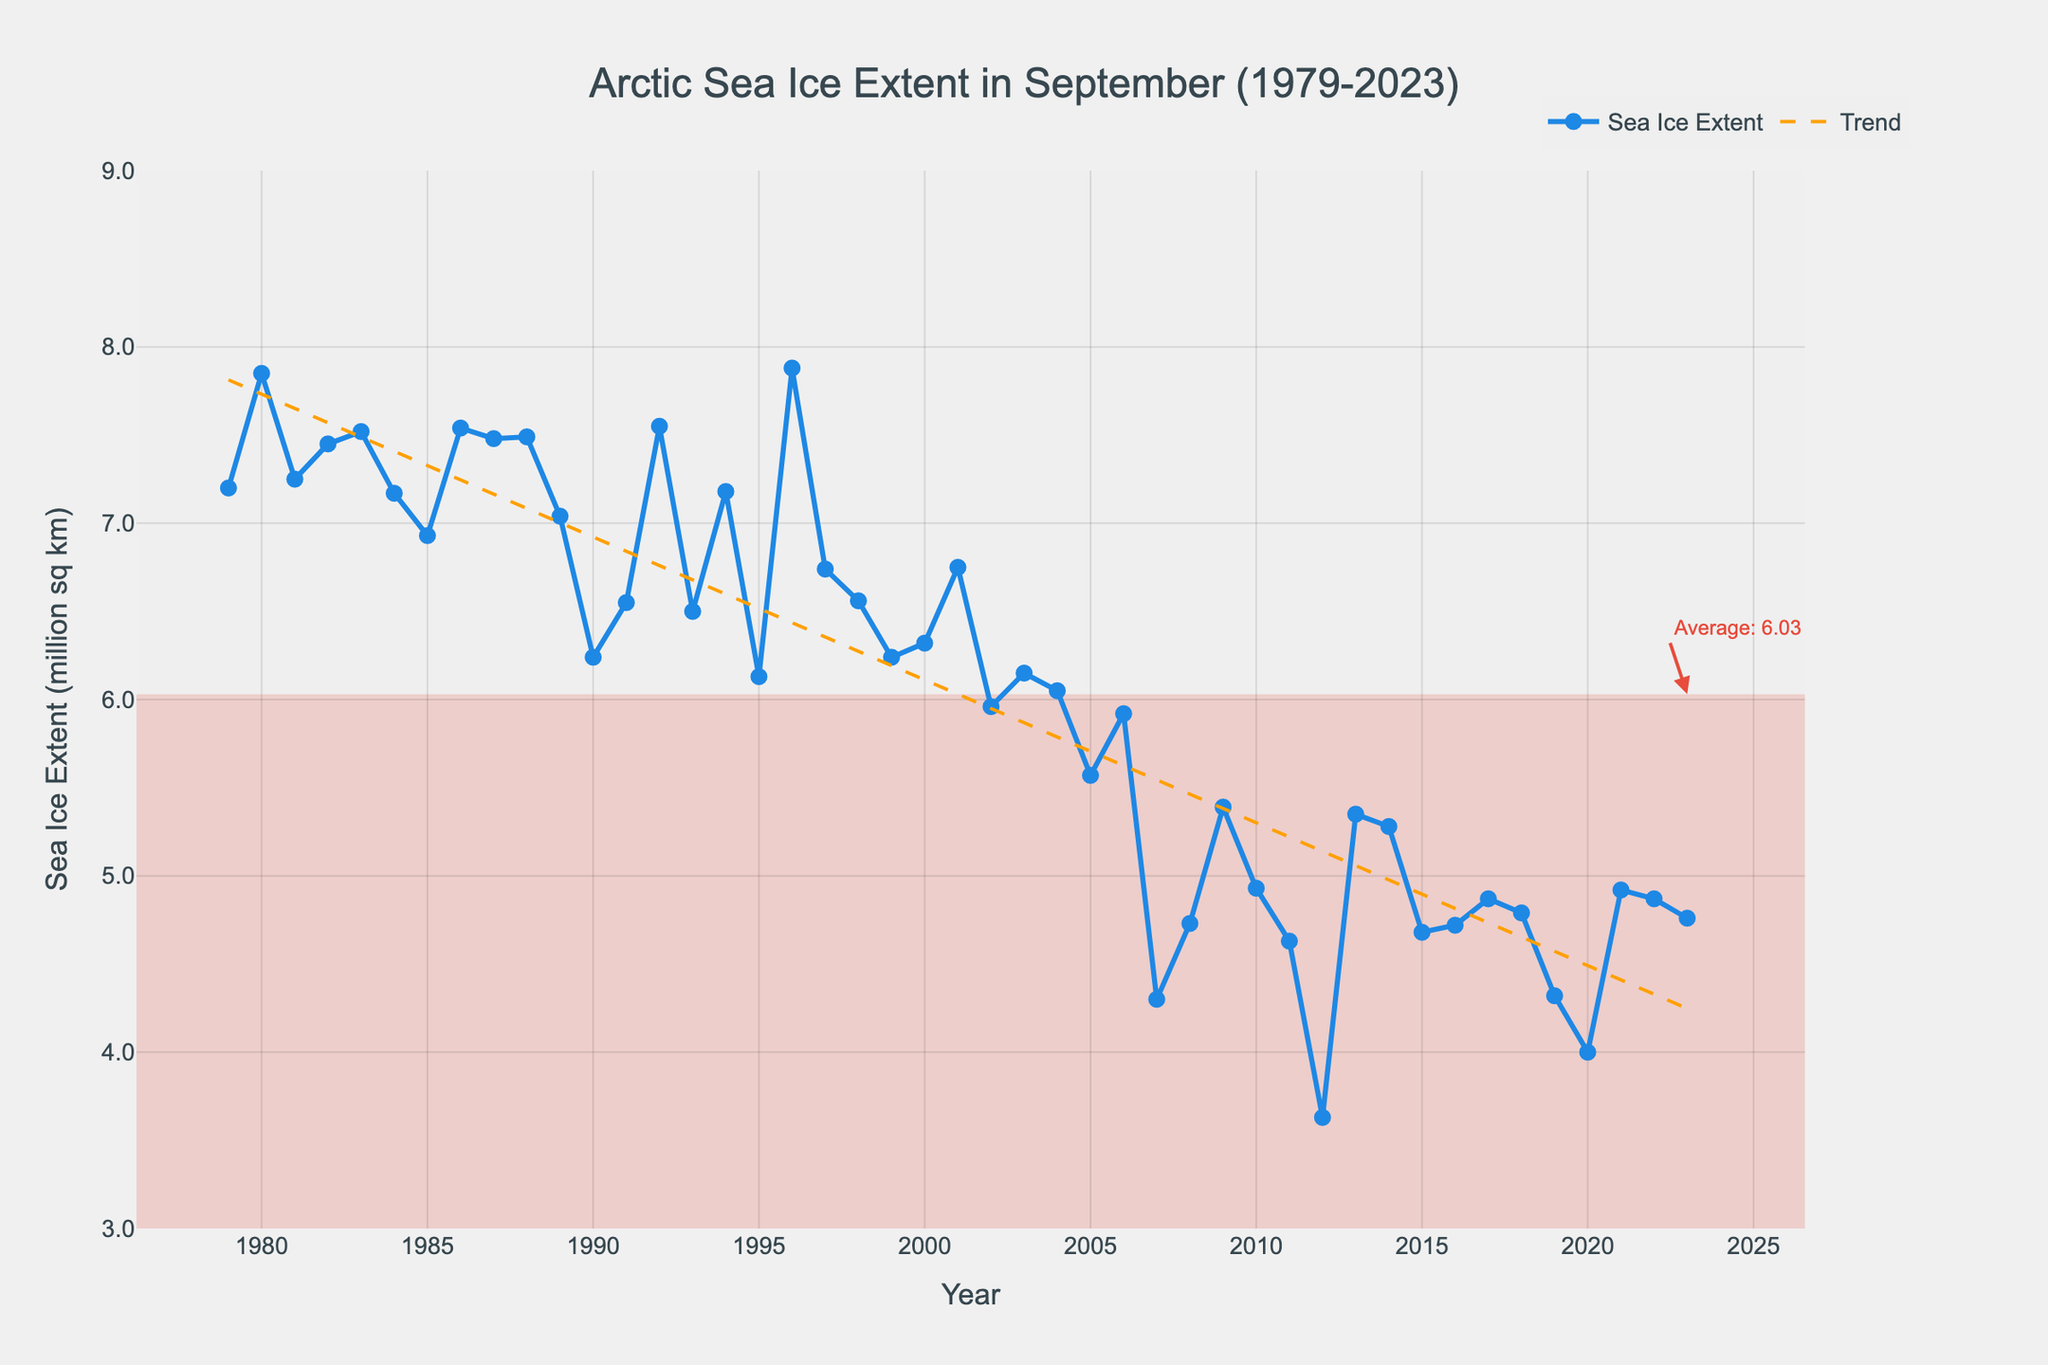what trend can be observed in the Arctic sea ice extent from 1979 to 2023? The trend line shows a decline in the sea ice extent from 1979 to 2023. This is depicted by the negative slope of the trend line, indicating that the extent of the sea ice in September has been decreasing steadily over the years.
Answer: Decreasing When was the lowest sea ice extent recorded, and what was its value? The lowest sea ice extent was recorded in the year 2012, as seen by the lowest point on the line chart, and its value was around 3.63 million sq km.
Answer: 2012, 3.63 million sq km How does the sea ice extent in 2023 compare to the average sea ice extent? The average sea ice extent is indicated by an annotation in the plot, and the average value is around 5.87 million sq km. The value for 2023 is 4.76 million sq km, which is below the average value.
Answer: Below average What year marked the first time the sea ice extent dropped below 5 million sq km? By observing the line chart, the first time the sea ice extent dropped below 5 million sq km was in 2007. The line dips below this value starting that year.
Answer: 2007 Which five-year period saw the greatest decline in sea ice extent? Comparing consecutive five-year periods, the largest decline appears between the periods 2007-2011 and 2012-2016. This is identified by the steep drop in the trend line during these years, with a particularly large drop in 2012.
Answer: 2007-2011 and 2012-2016 How many times did the September sea ice extent fall below 4.5 million sq km? By counting the points on the line chart that are below 4.5 million sq km, we observe that the September sea ice extent fell below this value in the following years: 2007, 2010, 2011, 2012, 2015, 2016, 2018, 2019, and 2020.
Answer: 9 times What was the sea ice extent in the year 1996, and how does it compare to the value in 2023? By referring to the figure, the sea ice extent in 1996 was 7.88 million sq km. Comparing this to the 2023 extent of 4.76 million sq km, we see a significant decrease.
Answer: 7.88 million sq km, lower in 2023 What is the general pattern of sea ice extent from 1979 to 2000, and how does it differ from the pattern from 2000 to 2023? The general pattern from 1979 to 2000 shows a slow decline with fluctuations. However, from 2000 to 2023, the decline became steeper and more consistent, indicating a more rapid loss of sea ice in the latter period.
Answer: Slow decline, then steeper decline What was the maximum value of the September sea ice extent, and in which year did it occur? The maximum value can be identified by looking for the highest peak on the line chart, which occurred around 1996 with a sea ice extent of approximately 7.88 million sq km.
Answer: 7.88 million sq km, 1996 